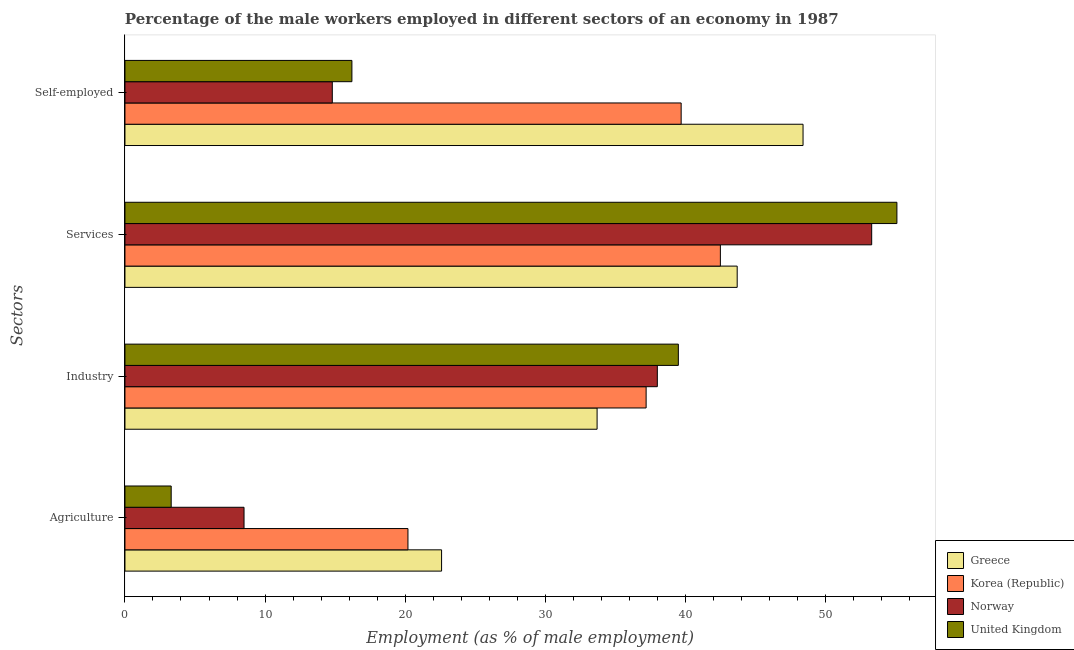How many groups of bars are there?
Your answer should be very brief. 4. How many bars are there on the 4th tick from the top?
Your response must be concise. 4. How many bars are there on the 3rd tick from the bottom?
Give a very brief answer. 4. What is the label of the 2nd group of bars from the top?
Provide a succinct answer. Services. What is the percentage of male workers in services in Norway?
Give a very brief answer. 53.3. Across all countries, what is the maximum percentage of male workers in agriculture?
Your answer should be compact. 22.6. Across all countries, what is the minimum percentage of male workers in industry?
Provide a succinct answer. 33.7. In which country was the percentage of male workers in industry minimum?
Make the answer very short. Greece. What is the total percentage of self employed male workers in the graph?
Offer a very short reply. 119.1. What is the difference between the percentage of male workers in agriculture in Greece and that in Norway?
Offer a terse response. 14.1. What is the difference between the percentage of male workers in services in United Kingdom and the percentage of male workers in industry in Korea (Republic)?
Ensure brevity in your answer.  17.9. What is the average percentage of self employed male workers per country?
Give a very brief answer. 29.78. What is the difference between the percentage of male workers in agriculture and percentage of self employed male workers in United Kingdom?
Offer a very short reply. -12.9. In how many countries, is the percentage of self employed male workers greater than 8 %?
Make the answer very short. 4. What is the ratio of the percentage of male workers in industry in Korea (Republic) to that in Norway?
Your answer should be compact. 0.98. Is the percentage of self employed male workers in Norway less than that in Greece?
Offer a terse response. Yes. Is the difference between the percentage of male workers in services in United Kingdom and Norway greater than the difference between the percentage of male workers in industry in United Kingdom and Norway?
Offer a very short reply. Yes. What is the difference between the highest and the second highest percentage of male workers in services?
Provide a short and direct response. 1.8. What is the difference between the highest and the lowest percentage of male workers in agriculture?
Keep it short and to the point. 19.3. In how many countries, is the percentage of self employed male workers greater than the average percentage of self employed male workers taken over all countries?
Your response must be concise. 2. Is the sum of the percentage of male workers in agriculture in Norway and United Kingdom greater than the maximum percentage of self employed male workers across all countries?
Give a very brief answer. No. Is it the case that in every country, the sum of the percentage of male workers in services and percentage of male workers in industry is greater than the sum of percentage of male workers in agriculture and percentage of self employed male workers?
Make the answer very short. No. What does the 1st bar from the bottom in Services represents?
Give a very brief answer. Greece. How many bars are there?
Make the answer very short. 16. Are all the bars in the graph horizontal?
Provide a short and direct response. Yes. How many countries are there in the graph?
Keep it short and to the point. 4. Are the values on the major ticks of X-axis written in scientific E-notation?
Your response must be concise. No. Does the graph contain grids?
Your answer should be compact. No. What is the title of the graph?
Ensure brevity in your answer.  Percentage of the male workers employed in different sectors of an economy in 1987. Does "Sierra Leone" appear as one of the legend labels in the graph?
Give a very brief answer. No. What is the label or title of the X-axis?
Give a very brief answer. Employment (as % of male employment). What is the label or title of the Y-axis?
Offer a very short reply. Sectors. What is the Employment (as % of male employment) of Greece in Agriculture?
Provide a short and direct response. 22.6. What is the Employment (as % of male employment) in Korea (Republic) in Agriculture?
Keep it short and to the point. 20.2. What is the Employment (as % of male employment) in Norway in Agriculture?
Offer a terse response. 8.5. What is the Employment (as % of male employment) of United Kingdom in Agriculture?
Your answer should be very brief. 3.3. What is the Employment (as % of male employment) in Greece in Industry?
Your response must be concise. 33.7. What is the Employment (as % of male employment) of Korea (Republic) in Industry?
Your answer should be very brief. 37.2. What is the Employment (as % of male employment) in United Kingdom in Industry?
Provide a short and direct response. 39.5. What is the Employment (as % of male employment) of Greece in Services?
Your answer should be very brief. 43.7. What is the Employment (as % of male employment) in Korea (Republic) in Services?
Your answer should be compact. 42.5. What is the Employment (as % of male employment) in Norway in Services?
Give a very brief answer. 53.3. What is the Employment (as % of male employment) in United Kingdom in Services?
Offer a very short reply. 55.1. What is the Employment (as % of male employment) in Greece in Self-employed?
Your response must be concise. 48.4. What is the Employment (as % of male employment) of Korea (Republic) in Self-employed?
Your response must be concise. 39.7. What is the Employment (as % of male employment) in Norway in Self-employed?
Offer a very short reply. 14.8. What is the Employment (as % of male employment) in United Kingdom in Self-employed?
Keep it short and to the point. 16.2. Across all Sectors, what is the maximum Employment (as % of male employment) of Greece?
Keep it short and to the point. 48.4. Across all Sectors, what is the maximum Employment (as % of male employment) of Korea (Republic)?
Offer a terse response. 42.5. Across all Sectors, what is the maximum Employment (as % of male employment) in Norway?
Provide a succinct answer. 53.3. Across all Sectors, what is the maximum Employment (as % of male employment) of United Kingdom?
Offer a very short reply. 55.1. Across all Sectors, what is the minimum Employment (as % of male employment) of Greece?
Offer a terse response. 22.6. Across all Sectors, what is the minimum Employment (as % of male employment) in Korea (Republic)?
Your answer should be compact. 20.2. Across all Sectors, what is the minimum Employment (as % of male employment) in Norway?
Your response must be concise. 8.5. Across all Sectors, what is the minimum Employment (as % of male employment) in United Kingdom?
Ensure brevity in your answer.  3.3. What is the total Employment (as % of male employment) in Greece in the graph?
Offer a terse response. 148.4. What is the total Employment (as % of male employment) of Korea (Republic) in the graph?
Provide a short and direct response. 139.6. What is the total Employment (as % of male employment) of Norway in the graph?
Your response must be concise. 114.6. What is the total Employment (as % of male employment) in United Kingdom in the graph?
Ensure brevity in your answer.  114.1. What is the difference between the Employment (as % of male employment) in Greece in Agriculture and that in Industry?
Your answer should be compact. -11.1. What is the difference between the Employment (as % of male employment) in Norway in Agriculture and that in Industry?
Make the answer very short. -29.5. What is the difference between the Employment (as % of male employment) in United Kingdom in Agriculture and that in Industry?
Ensure brevity in your answer.  -36.2. What is the difference between the Employment (as % of male employment) in Greece in Agriculture and that in Services?
Your answer should be compact. -21.1. What is the difference between the Employment (as % of male employment) of Korea (Republic) in Agriculture and that in Services?
Ensure brevity in your answer.  -22.3. What is the difference between the Employment (as % of male employment) of Norway in Agriculture and that in Services?
Your answer should be compact. -44.8. What is the difference between the Employment (as % of male employment) of United Kingdom in Agriculture and that in Services?
Keep it short and to the point. -51.8. What is the difference between the Employment (as % of male employment) in Greece in Agriculture and that in Self-employed?
Provide a succinct answer. -25.8. What is the difference between the Employment (as % of male employment) in Korea (Republic) in Agriculture and that in Self-employed?
Keep it short and to the point. -19.5. What is the difference between the Employment (as % of male employment) in Norway in Agriculture and that in Self-employed?
Ensure brevity in your answer.  -6.3. What is the difference between the Employment (as % of male employment) of Norway in Industry and that in Services?
Give a very brief answer. -15.3. What is the difference between the Employment (as % of male employment) in United Kingdom in Industry and that in Services?
Provide a short and direct response. -15.6. What is the difference between the Employment (as % of male employment) of Greece in Industry and that in Self-employed?
Provide a succinct answer. -14.7. What is the difference between the Employment (as % of male employment) of Norway in Industry and that in Self-employed?
Ensure brevity in your answer.  23.2. What is the difference between the Employment (as % of male employment) in United Kingdom in Industry and that in Self-employed?
Provide a succinct answer. 23.3. What is the difference between the Employment (as % of male employment) of Korea (Republic) in Services and that in Self-employed?
Your answer should be very brief. 2.8. What is the difference between the Employment (as % of male employment) in Norway in Services and that in Self-employed?
Keep it short and to the point. 38.5. What is the difference between the Employment (as % of male employment) in United Kingdom in Services and that in Self-employed?
Provide a succinct answer. 38.9. What is the difference between the Employment (as % of male employment) of Greece in Agriculture and the Employment (as % of male employment) of Korea (Republic) in Industry?
Provide a short and direct response. -14.6. What is the difference between the Employment (as % of male employment) in Greece in Agriculture and the Employment (as % of male employment) in Norway in Industry?
Make the answer very short. -15.4. What is the difference between the Employment (as % of male employment) of Greece in Agriculture and the Employment (as % of male employment) of United Kingdom in Industry?
Keep it short and to the point. -16.9. What is the difference between the Employment (as % of male employment) of Korea (Republic) in Agriculture and the Employment (as % of male employment) of Norway in Industry?
Ensure brevity in your answer.  -17.8. What is the difference between the Employment (as % of male employment) in Korea (Republic) in Agriculture and the Employment (as % of male employment) in United Kingdom in Industry?
Ensure brevity in your answer.  -19.3. What is the difference between the Employment (as % of male employment) in Norway in Agriculture and the Employment (as % of male employment) in United Kingdom in Industry?
Your answer should be very brief. -31. What is the difference between the Employment (as % of male employment) of Greece in Agriculture and the Employment (as % of male employment) of Korea (Republic) in Services?
Keep it short and to the point. -19.9. What is the difference between the Employment (as % of male employment) of Greece in Agriculture and the Employment (as % of male employment) of Norway in Services?
Ensure brevity in your answer.  -30.7. What is the difference between the Employment (as % of male employment) of Greece in Agriculture and the Employment (as % of male employment) of United Kingdom in Services?
Give a very brief answer. -32.5. What is the difference between the Employment (as % of male employment) in Korea (Republic) in Agriculture and the Employment (as % of male employment) in Norway in Services?
Provide a succinct answer. -33.1. What is the difference between the Employment (as % of male employment) in Korea (Republic) in Agriculture and the Employment (as % of male employment) in United Kingdom in Services?
Provide a succinct answer. -34.9. What is the difference between the Employment (as % of male employment) of Norway in Agriculture and the Employment (as % of male employment) of United Kingdom in Services?
Keep it short and to the point. -46.6. What is the difference between the Employment (as % of male employment) in Greece in Agriculture and the Employment (as % of male employment) in Korea (Republic) in Self-employed?
Your response must be concise. -17.1. What is the difference between the Employment (as % of male employment) in Greece in Agriculture and the Employment (as % of male employment) in Norway in Self-employed?
Offer a very short reply. 7.8. What is the difference between the Employment (as % of male employment) of Greece in Industry and the Employment (as % of male employment) of Korea (Republic) in Services?
Offer a terse response. -8.8. What is the difference between the Employment (as % of male employment) of Greece in Industry and the Employment (as % of male employment) of Norway in Services?
Give a very brief answer. -19.6. What is the difference between the Employment (as % of male employment) in Greece in Industry and the Employment (as % of male employment) in United Kingdom in Services?
Ensure brevity in your answer.  -21.4. What is the difference between the Employment (as % of male employment) of Korea (Republic) in Industry and the Employment (as % of male employment) of Norway in Services?
Make the answer very short. -16.1. What is the difference between the Employment (as % of male employment) of Korea (Republic) in Industry and the Employment (as % of male employment) of United Kingdom in Services?
Keep it short and to the point. -17.9. What is the difference between the Employment (as % of male employment) in Norway in Industry and the Employment (as % of male employment) in United Kingdom in Services?
Give a very brief answer. -17.1. What is the difference between the Employment (as % of male employment) in Greece in Industry and the Employment (as % of male employment) in Norway in Self-employed?
Give a very brief answer. 18.9. What is the difference between the Employment (as % of male employment) in Greece in Industry and the Employment (as % of male employment) in United Kingdom in Self-employed?
Your response must be concise. 17.5. What is the difference between the Employment (as % of male employment) of Korea (Republic) in Industry and the Employment (as % of male employment) of Norway in Self-employed?
Offer a terse response. 22.4. What is the difference between the Employment (as % of male employment) of Korea (Republic) in Industry and the Employment (as % of male employment) of United Kingdom in Self-employed?
Offer a very short reply. 21. What is the difference between the Employment (as % of male employment) of Norway in Industry and the Employment (as % of male employment) of United Kingdom in Self-employed?
Make the answer very short. 21.8. What is the difference between the Employment (as % of male employment) of Greece in Services and the Employment (as % of male employment) of Korea (Republic) in Self-employed?
Give a very brief answer. 4. What is the difference between the Employment (as % of male employment) of Greece in Services and the Employment (as % of male employment) of Norway in Self-employed?
Ensure brevity in your answer.  28.9. What is the difference between the Employment (as % of male employment) of Greece in Services and the Employment (as % of male employment) of United Kingdom in Self-employed?
Offer a very short reply. 27.5. What is the difference between the Employment (as % of male employment) of Korea (Republic) in Services and the Employment (as % of male employment) of Norway in Self-employed?
Offer a terse response. 27.7. What is the difference between the Employment (as % of male employment) in Korea (Republic) in Services and the Employment (as % of male employment) in United Kingdom in Self-employed?
Make the answer very short. 26.3. What is the difference between the Employment (as % of male employment) in Norway in Services and the Employment (as % of male employment) in United Kingdom in Self-employed?
Keep it short and to the point. 37.1. What is the average Employment (as % of male employment) in Greece per Sectors?
Provide a succinct answer. 37.1. What is the average Employment (as % of male employment) of Korea (Republic) per Sectors?
Offer a terse response. 34.9. What is the average Employment (as % of male employment) in Norway per Sectors?
Your answer should be compact. 28.65. What is the average Employment (as % of male employment) of United Kingdom per Sectors?
Keep it short and to the point. 28.52. What is the difference between the Employment (as % of male employment) in Greece and Employment (as % of male employment) in Korea (Republic) in Agriculture?
Your response must be concise. 2.4. What is the difference between the Employment (as % of male employment) of Greece and Employment (as % of male employment) of United Kingdom in Agriculture?
Ensure brevity in your answer.  19.3. What is the difference between the Employment (as % of male employment) in Korea (Republic) and Employment (as % of male employment) in Norway in Agriculture?
Provide a succinct answer. 11.7. What is the difference between the Employment (as % of male employment) of Greece and Employment (as % of male employment) of Korea (Republic) in Industry?
Offer a terse response. -3.5. What is the difference between the Employment (as % of male employment) in Greece and Employment (as % of male employment) in Norway in Industry?
Keep it short and to the point. -4.3. What is the difference between the Employment (as % of male employment) of Greece and Employment (as % of male employment) of United Kingdom in Industry?
Give a very brief answer. -5.8. What is the difference between the Employment (as % of male employment) of Korea (Republic) and Employment (as % of male employment) of Norway in Industry?
Offer a terse response. -0.8. What is the difference between the Employment (as % of male employment) of Korea (Republic) and Employment (as % of male employment) of United Kingdom in Industry?
Offer a terse response. -2.3. What is the difference between the Employment (as % of male employment) in Greece and Employment (as % of male employment) in Korea (Republic) in Services?
Your answer should be very brief. 1.2. What is the difference between the Employment (as % of male employment) of Greece and Employment (as % of male employment) of Korea (Republic) in Self-employed?
Ensure brevity in your answer.  8.7. What is the difference between the Employment (as % of male employment) of Greece and Employment (as % of male employment) of Norway in Self-employed?
Your response must be concise. 33.6. What is the difference between the Employment (as % of male employment) in Greece and Employment (as % of male employment) in United Kingdom in Self-employed?
Your answer should be very brief. 32.2. What is the difference between the Employment (as % of male employment) of Korea (Republic) and Employment (as % of male employment) of Norway in Self-employed?
Provide a succinct answer. 24.9. What is the ratio of the Employment (as % of male employment) of Greece in Agriculture to that in Industry?
Keep it short and to the point. 0.67. What is the ratio of the Employment (as % of male employment) in Korea (Republic) in Agriculture to that in Industry?
Provide a short and direct response. 0.54. What is the ratio of the Employment (as % of male employment) in Norway in Agriculture to that in Industry?
Make the answer very short. 0.22. What is the ratio of the Employment (as % of male employment) in United Kingdom in Agriculture to that in Industry?
Your answer should be very brief. 0.08. What is the ratio of the Employment (as % of male employment) of Greece in Agriculture to that in Services?
Your response must be concise. 0.52. What is the ratio of the Employment (as % of male employment) in Korea (Republic) in Agriculture to that in Services?
Ensure brevity in your answer.  0.48. What is the ratio of the Employment (as % of male employment) of Norway in Agriculture to that in Services?
Ensure brevity in your answer.  0.16. What is the ratio of the Employment (as % of male employment) in United Kingdom in Agriculture to that in Services?
Keep it short and to the point. 0.06. What is the ratio of the Employment (as % of male employment) in Greece in Agriculture to that in Self-employed?
Keep it short and to the point. 0.47. What is the ratio of the Employment (as % of male employment) in Korea (Republic) in Agriculture to that in Self-employed?
Ensure brevity in your answer.  0.51. What is the ratio of the Employment (as % of male employment) in Norway in Agriculture to that in Self-employed?
Give a very brief answer. 0.57. What is the ratio of the Employment (as % of male employment) in United Kingdom in Agriculture to that in Self-employed?
Your answer should be compact. 0.2. What is the ratio of the Employment (as % of male employment) of Greece in Industry to that in Services?
Give a very brief answer. 0.77. What is the ratio of the Employment (as % of male employment) in Korea (Republic) in Industry to that in Services?
Offer a terse response. 0.88. What is the ratio of the Employment (as % of male employment) of Norway in Industry to that in Services?
Your response must be concise. 0.71. What is the ratio of the Employment (as % of male employment) of United Kingdom in Industry to that in Services?
Give a very brief answer. 0.72. What is the ratio of the Employment (as % of male employment) in Greece in Industry to that in Self-employed?
Provide a succinct answer. 0.7. What is the ratio of the Employment (as % of male employment) of Korea (Republic) in Industry to that in Self-employed?
Your response must be concise. 0.94. What is the ratio of the Employment (as % of male employment) of Norway in Industry to that in Self-employed?
Give a very brief answer. 2.57. What is the ratio of the Employment (as % of male employment) in United Kingdom in Industry to that in Self-employed?
Keep it short and to the point. 2.44. What is the ratio of the Employment (as % of male employment) in Greece in Services to that in Self-employed?
Ensure brevity in your answer.  0.9. What is the ratio of the Employment (as % of male employment) of Korea (Republic) in Services to that in Self-employed?
Offer a terse response. 1.07. What is the ratio of the Employment (as % of male employment) in Norway in Services to that in Self-employed?
Your answer should be compact. 3.6. What is the ratio of the Employment (as % of male employment) in United Kingdom in Services to that in Self-employed?
Make the answer very short. 3.4. What is the difference between the highest and the second highest Employment (as % of male employment) of Korea (Republic)?
Your response must be concise. 2.8. What is the difference between the highest and the second highest Employment (as % of male employment) of Norway?
Your response must be concise. 15.3. What is the difference between the highest and the second highest Employment (as % of male employment) in United Kingdom?
Provide a succinct answer. 15.6. What is the difference between the highest and the lowest Employment (as % of male employment) in Greece?
Your answer should be very brief. 25.8. What is the difference between the highest and the lowest Employment (as % of male employment) in Korea (Republic)?
Give a very brief answer. 22.3. What is the difference between the highest and the lowest Employment (as % of male employment) in Norway?
Provide a short and direct response. 44.8. What is the difference between the highest and the lowest Employment (as % of male employment) of United Kingdom?
Your answer should be very brief. 51.8. 